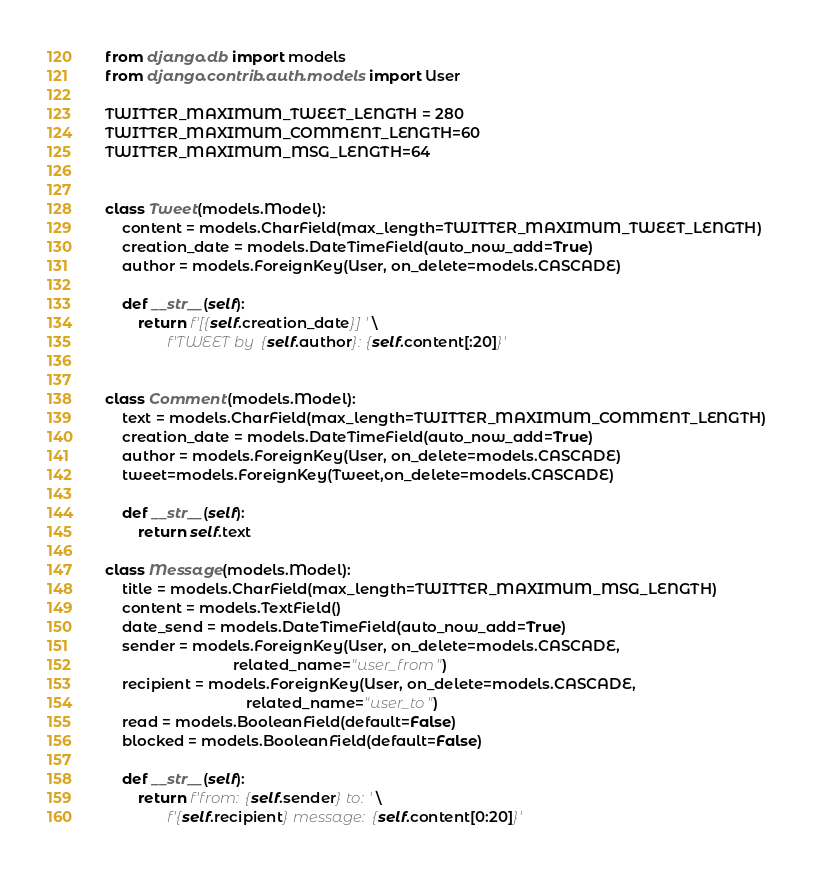<code> <loc_0><loc_0><loc_500><loc_500><_Python_>from django.db import models
from django.contrib.auth.models import User

TWITTER_MAXIMUM_TWEET_LENGTH = 280
TWITTER_MAXIMUM_COMMENT_LENGTH=60
TWITTER_MAXIMUM_MSG_LENGTH=64


class Tweet(models.Model):
    content = models.CharField(max_length=TWITTER_MAXIMUM_TWEET_LENGTH)
    creation_date = models.DateTimeField(auto_now_add=True)
    author = models.ForeignKey(User, on_delete=models.CASCADE)

    def __str__(self):
        return f'[{self.creation_date}] ' \
               f'TWEET by {self.author}: {self.content[:20]}'


class Comment(models.Model):
    text = models.CharField(max_length=TWITTER_MAXIMUM_COMMENT_LENGTH)
    creation_date = models.DateTimeField(auto_now_add=True)
    author = models.ForeignKey(User, on_delete=models.CASCADE)
    tweet=models.ForeignKey(Tweet,on_delete=models.CASCADE)

    def __str__(self):
        return self.text

class Message(models.Model):
    title = models.CharField(max_length=TWITTER_MAXIMUM_MSG_LENGTH)
    content = models.TextField()
    date_send = models.DateTimeField(auto_now_add=True)
    sender = models.ForeignKey(User, on_delete=models.CASCADE,
                               related_name="user_from")
    recipient = models.ForeignKey(User, on_delete=models.CASCADE,
                                  related_name="user_to")
    read = models.BooleanField(default=False)
    blocked = models.BooleanField(default=False)

    def __str__(self):
        return f'from: {self.sender} to: ' \
               f'{self.recipient} message: {self.content[0:20]}'
</code> 